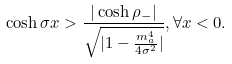<formula> <loc_0><loc_0><loc_500><loc_500>\cosh \sigma x > \frac { | \cosh \rho _ { - } | } { \sqrt { | 1 - \frac { m _ { a } ^ { 4 } } { 4 \sigma ^ { 2 } } | } } , \forall x < 0 .</formula> 